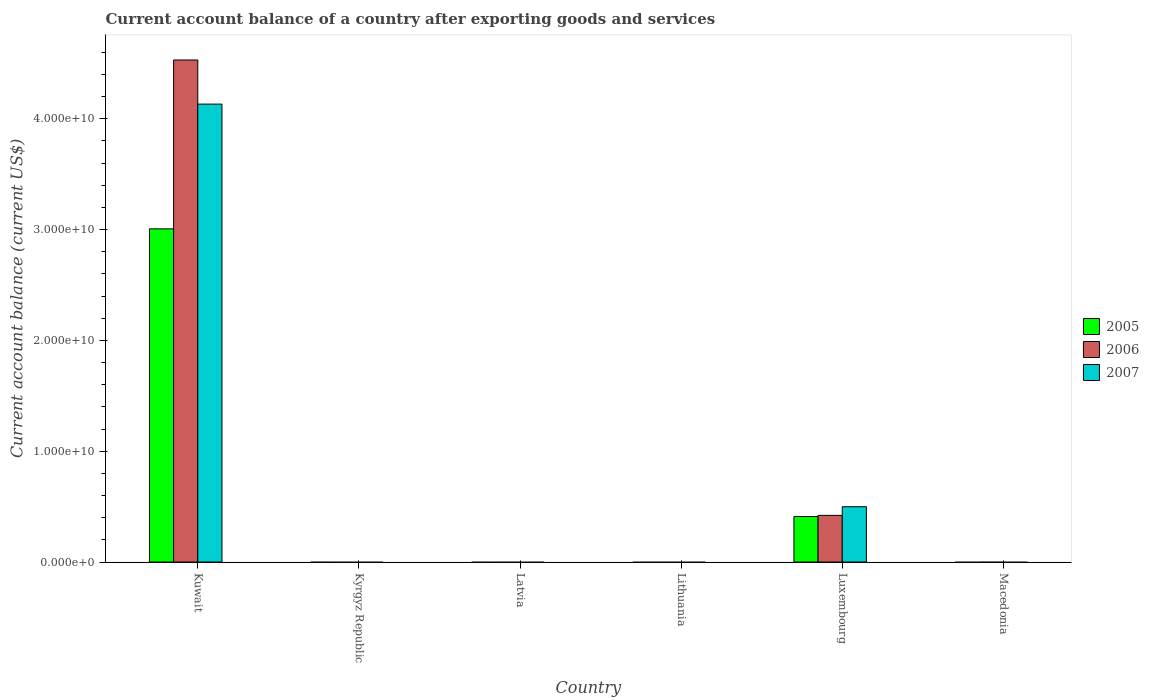How many different coloured bars are there?
Keep it short and to the point. 3. Are the number of bars on each tick of the X-axis equal?
Ensure brevity in your answer.  No. What is the label of the 3rd group of bars from the left?
Your answer should be compact. Latvia. Across all countries, what is the maximum account balance in 2006?
Your response must be concise. 4.53e+1. Across all countries, what is the minimum account balance in 2005?
Provide a succinct answer. 0. In which country was the account balance in 2005 maximum?
Ensure brevity in your answer.  Kuwait. What is the total account balance in 2005 in the graph?
Your response must be concise. 3.42e+1. What is the difference between the account balance in 2005 in Kuwait and that in Luxembourg?
Offer a terse response. 2.60e+1. What is the difference between the account balance in 2006 in Luxembourg and the account balance in 2007 in Lithuania?
Make the answer very short. 4.21e+09. What is the average account balance in 2007 per country?
Provide a short and direct response. 7.72e+09. What is the difference between the account balance of/in 2007 and account balance of/in 2005 in Luxembourg?
Offer a very short reply. 8.85e+08. In how many countries, is the account balance in 2005 greater than 28000000000 US$?
Make the answer very short. 1. What is the difference between the highest and the lowest account balance in 2005?
Keep it short and to the point. 3.01e+1. In how many countries, is the account balance in 2007 greater than the average account balance in 2007 taken over all countries?
Offer a very short reply. 1. How many bars are there?
Your response must be concise. 6. How many countries are there in the graph?
Make the answer very short. 6. Does the graph contain any zero values?
Make the answer very short. Yes. How are the legend labels stacked?
Your answer should be compact. Vertical. What is the title of the graph?
Give a very brief answer. Current account balance of a country after exporting goods and services. Does "2000" appear as one of the legend labels in the graph?
Give a very brief answer. No. What is the label or title of the X-axis?
Give a very brief answer. Country. What is the label or title of the Y-axis?
Your answer should be very brief. Current account balance (current US$). What is the Current account balance (current US$) in 2005 in Kuwait?
Make the answer very short. 3.01e+1. What is the Current account balance (current US$) in 2006 in Kuwait?
Offer a terse response. 4.53e+1. What is the Current account balance (current US$) in 2007 in Kuwait?
Your answer should be very brief. 4.13e+1. What is the Current account balance (current US$) of 2006 in Kyrgyz Republic?
Give a very brief answer. 0. What is the Current account balance (current US$) of 2006 in Latvia?
Make the answer very short. 0. What is the Current account balance (current US$) in 2005 in Lithuania?
Provide a succinct answer. 0. What is the Current account balance (current US$) in 2006 in Lithuania?
Ensure brevity in your answer.  0. What is the Current account balance (current US$) of 2005 in Luxembourg?
Your answer should be very brief. 4.11e+09. What is the Current account balance (current US$) of 2006 in Luxembourg?
Give a very brief answer. 4.21e+09. What is the Current account balance (current US$) of 2007 in Luxembourg?
Your response must be concise. 4.99e+09. What is the Current account balance (current US$) in 2005 in Macedonia?
Your answer should be compact. 0. Across all countries, what is the maximum Current account balance (current US$) of 2005?
Make the answer very short. 3.01e+1. Across all countries, what is the maximum Current account balance (current US$) of 2006?
Ensure brevity in your answer.  4.53e+1. Across all countries, what is the maximum Current account balance (current US$) of 2007?
Make the answer very short. 4.13e+1. Across all countries, what is the minimum Current account balance (current US$) in 2005?
Give a very brief answer. 0. Across all countries, what is the minimum Current account balance (current US$) of 2006?
Ensure brevity in your answer.  0. Across all countries, what is the minimum Current account balance (current US$) in 2007?
Your answer should be compact. 0. What is the total Current account balance (current US$) in 2005 in the graph?
Give a very brief answer. 3.42e+1. What is the total Current account balance (current US$) in 2006 in the graph?
Offer a terse response. 4.95e+1. What is the total Current account balance (current US$) in 2007 in the graph?
Keep it short and to the point. 4.63e+1. What is the difference between the Current account balance (current US$) in 2005 in Kuwait and that in Luxembourg?
Your response must be concise. 2.60e+1. What is the difference between the Current account balance (current US$) of 2006 in Kuwait and that in Luxembourg?
Offer a very short reply. 4.11e+1. What is the difference between the Current account balance (current US$) in 2007 in Kuwait and that in Luxembourg?
Provide a short and direct response. 3.63e+1. What is the difference between the Current account balance (current US$) of 2005 in Kuwait and the Current account balance (current US$) of 2006 in Luxembourg?
Ensure brevity in your answer.  2.59e+1. What is the difference between the Current account balance (current US$) in 2005 in Kuwait and the Current account balance (current US$) in 2007 in Luxembourg?
Provide a short and direct response. 2.51e+1. What is the difference between the Current account balance (current US$) in 2006 in Kuwait and the Current account balance (current US$) in 2007 in Luxembourg?
Your answer should be compact. 4.03e+1. What is the average Current account balance (current US$) in 2005 per country?
Give a very brief answer. 5.70e+09. What is the average Current account balance (current US$) in 2006 per country?
Your response must be concise. 8.25e+09. What is the average Current account balance (current US$) in 2007 per country?
Your answer should be compact. 7.72e+09. What is the difference between the Current account balance (current US$) in 2005 and Current account balance (current US$) in 2006 in Kuwait?
Provide a short and direct response. -1.52e+1. What is the difference between the Current account balance (current US$) of 2005 and Current account balance (current US$) of 2007 in Kuwait?
Your response must be concise. -1.13e+1. What is the difference between the Current account balance (current US$) in 2006 and Current account balance (current US$) in 2007 in Kuwait?
Provide a succinct answer. 3.98e+09. What is the difference between the Current account balance (current US$) in 2005 and Current account balance (current US$) in 2006 in Luxembourg?
Your answer should be very brief. -1.04e+08. What is the difference between the Current account balance (current US$) in 2005 and Current account balance (current US$) in 2007 in Luxembourg?
Keep it short and to the point. -8.85e+08. What is the difference between the Current account balance (current US$) of 2006 and Current account balance (current US$) of 2007 in Luxembourg?
Make the answer very short. -7.80e+08. What is the ratio of the Current account balance (current US$) in 2005 in Kuwait to that in Luxembourg?
Offer a terse response. 7.32. What is the ratio of the Current account balance (current US$) of 2006 in Kuwait to that in Luxembourg?
Your answer should be very brief. 10.76. What is the ratio of the Current account balance (current US$) in 2007 in Kuwait to that in Luxembourg?
Provide a short and direct response. 8.28. What is the difference between the highest and the lowest Current account balance (current US$) in 2005?
Ensure brevity in your answer.  3.01e+1. What is the difference between the highest and the lowest Current account balance (current US$) of 2006?
Keep it short and to the point. 4.53e+1. What is the difference between the highest and the lowest Current account balance (current US$) in 2007?
Give a very brief answer. 4.13e+1. 